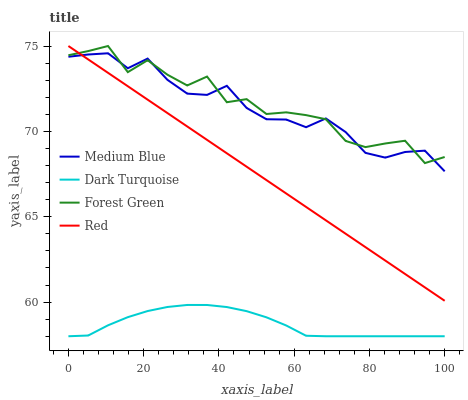Does Dark Turquoise have the minimum area under the curve?
Answer yes or no. Yes. Does Forest Green have the maximum area under the curve?
Answer yes or no. Yes. Does Medium Blue have the minimum area under the curve?
Answer yes or no. No. Does Medium Blue have the maximum area under the curve?
Answer yes or no. No. Is Red the smoothest?
Answer yes or no. Yes. Is Forest Green the roughest?
Answer yes or no. Yes. Is Medium Blue the smoothest?
Answer yes or no. No. Is Medium Blue the roughest?
Answer yes or no. No. Does Medium Blue have the lowest value?
Answer yes or no. No. Does Red have the highest value?
Answer yes or no. Yes. Does Medium Blue have the highest value?
Answer yes or no. No. Is Dark Turquoise less than Medium Blue?
Answer yes or no. Yes. Is Medium Blue greater than Dark Turquoise?
Answer yes or no. Yes. Does Medium Blue intersect Forest Green?
Answer yes or no. Yes. Is Medium Blue less than Forest Green?
Answer yes or no. No. Is Medium Blue greater than Forest Green?
Answer yes or no. No. Does Dark Turquoise intersect Medium Blue?
Answer yes or no. No. 